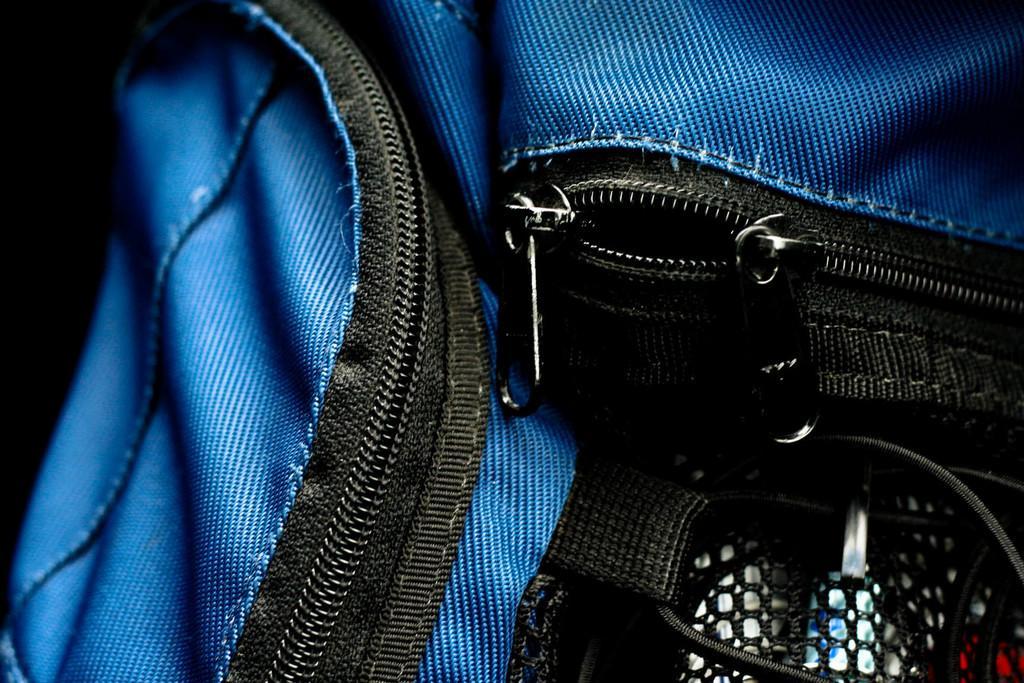Could you give a brief overview of what you see in this image? In this picture there is a bag which is in blue color, There are some chains on the bag which are in black color. 